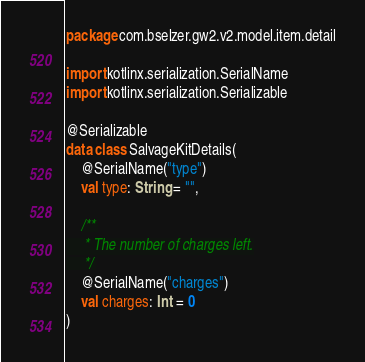Convert code to text. <code><loc_0><loc_0><loc_500><loc_500><_Kotlin_>package com.bselzer.gw2.v2.model.item.detail

import kotlinx.serialization.SerialName
import kotlinx.serialization.Serializable

@Serializable
data class SalvageKitDetails(
    @SerialName("type")
    val type: String = "",

    /**
     * The number of charges left.
     */
    @SerialName("charges")
    val charges: Int = 0
)</code> 